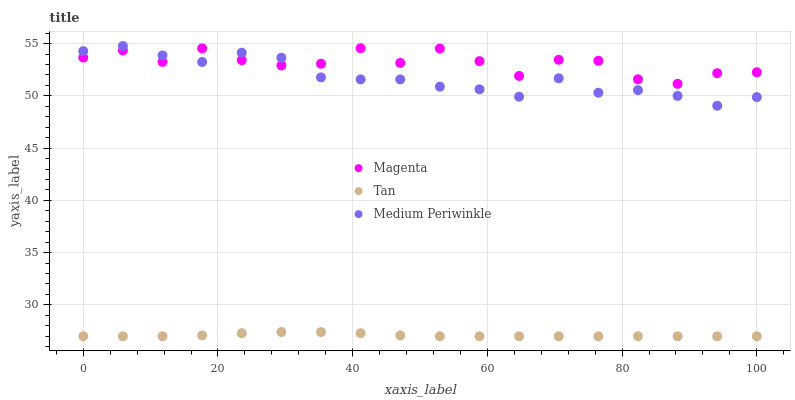Does Tan have the minimum area under the curve?
Answer yes or no. Yes. Does Magenta have the maximum area under the curve?
Answer yes or no. Yes. Does Medium Periwinkle have the minimum area under the curve?
Answer yes or no. No. Does Medium Periwinkle have the maximum area under the curve?
Answer yes or no. No. Is Tan the smoothest?
Answer yes or no. Yes. Is Magenta the roughest?
Answer yes or no. Yes. Is Medium Periwinkle the smoothest?
Answer yes or no. No. Is Medium Periwinkle the roughest?
Answer yes or no. No. Does Tan have the lowest value?
Answer yes or no. Yes. Does Medium Periwinkle have the lowest value?
Answer yes or no. No. Does Medium Periwinkle have the highest value?
Answer yes or no. Yes. Does Tan have the highest value?
Answer yes or no. No. Is Tan less than Medium Periwinkle?
Answer yes or no. Yes. Is Medium Periwinkle greater than Tan?
Answer yes or no. Yes. Does Medium Periwinkle intersect Magenta?
Answer yes or no. Yes. Is Medium Periwinkle less than Magenta?
Answer yes or no. No. Is Medium Periwinkle greater than Magenta?
Answer yes or no. No. Does Tan intersect Medium Periwinkle?
Answer yes or no. No. 